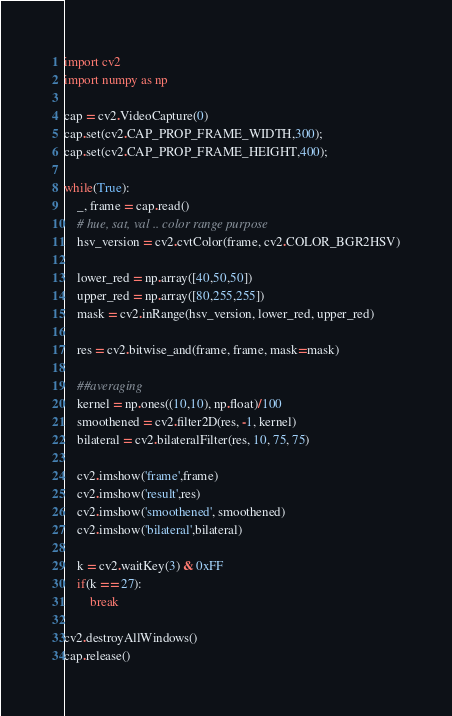<code> <loc_0><loc_0><loc_500><loc_500><_Python_>import cv2
import numpy as np 

cap = cv2.VideoCapture(0)
cap.set(cv2.CAP_PROP_FRAME_WIDTH,300);
cap.set(cv2.CAP_PROP_FRAME_HEIGHT,400);

while(True):
	_, frame = cap.read()
	# hue, sat, val .. color range purpose
	hsv_version = cv2.cvtColor(frame, cv2.COLOR_BGR2HSV)

	lower_red = np.array([40,50,50])
	upper_red = np.array([80,255,255])
	mask = cv2.inRange(hsv_version, lower_red, upper_red)

	res = cv2.bitwise_and(frame, frame, mask=mask)

	##averaging
	kernel = np.ones((10,10), np.float)/100
	smoothened = cv2.filter2D(res, -1, kernel)
	bilateral = cv2.bilateralFilter(res, 10, 75, 75)

	cv2.imshow('frame',frame)
	cv2.imshow('result',res)
	cv2.imshow('smoothened', smoothened)
	cv2.imshow('bilateral',bilateral)

	k = cv2.waitKey(3) & 0xFF
	if(k == 27):
		break

cv2.destroyAllWindows()
cap.release()


</code> 